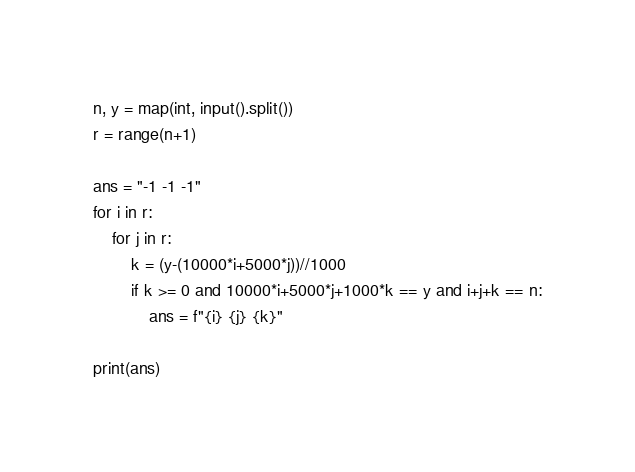Convert code to text. <code><loc_0><loc_0><loc_500><loc_500><_Python_>n, y = map(int, input().split())
r = range(n+1)

ans = "-1 -1 -1"
for i in r:
    for j in r:
        k = (y-(10000*i+5000*j))//1000
        if k >= 0 and 10000*i+5000*j+1000*k == y and i+j+k == n:
            ans = f"{i} {j} {k}"

print(ans)
</code> 